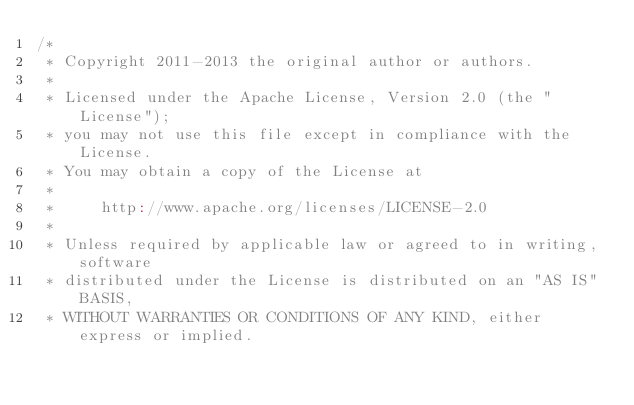Convert code to text. <code><loc_0><loc_0><loc_500><loc_500><_Scala_>/*
 * Copyright 2011-2013 the original author or authors.
 *
 * Licensed under the Apache License, Version 2.0 (the "License");
 * you may not use this file except in compliance with the License.
 * You may obtain a copy of the License at
 *
 *     http://www.apache.org/licenses/LICENSE-2.0
 *
 * Unless required by applicable law or agreed to in writing, software
 * distributed under the License is distributed on an "AS IS" BASIS,
 * WITHOUT WARRANTIES OR CONDITIONS OF ANY KIND, either express or implied.</code> 